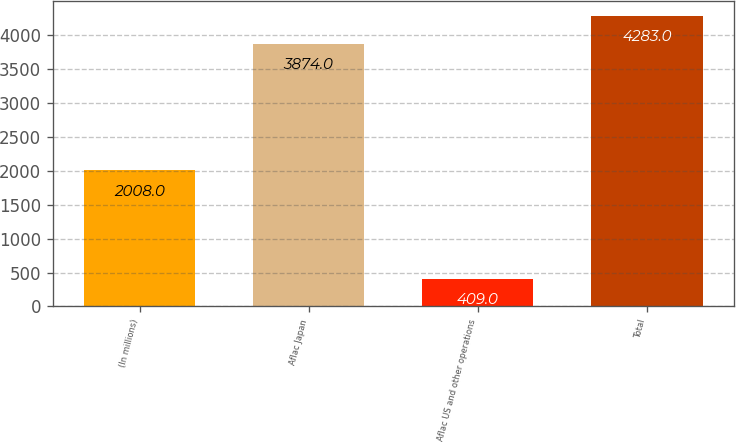Convert chart. <chart><loc_0><loc_0><loc_500><loc_500><bar_chart><fcel>(In millions)<fcel>Aflac Japan<fcel>Aflac US and other operations<fcel>Total<nl><fcel>2008<fcel>3874<fcel>409<fcel>4283<nl></chart> 